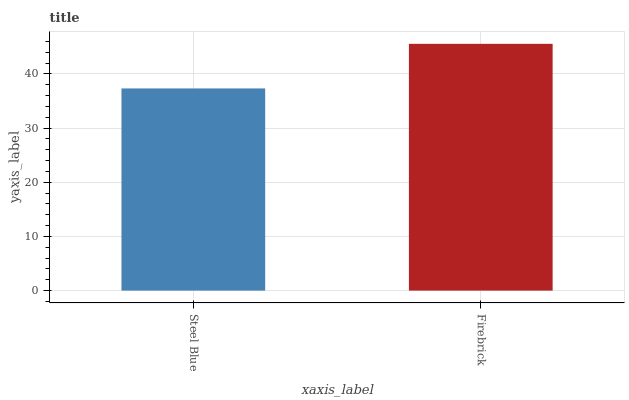Is Steel Blue the minimum?
Answer yes or no. Yes. Is Firebrick the maximum?
Answer yes or no. Yes. Is Firebrick the minimum?
Answer yes or no. No. Is Firebrick greater than Steel Blue?
Answer yes or no. Yes. Is Steel Blue less than Firebrick?
Answer yes or no. Yes. Is Steel Blue greater than Firebrick?
Answer yes or no. No. Is Firebrick less than Steel Blue?
Answer yes or no. No. Is Firebrick the high median?
Answer yes or no. Yes. Is Steel Blue the low median?
Answer yes or no. Yes. Is Steel Blue the high median?
Answer yes or no. No. Is Firebrick the low median?
Answer yes or no. No. 